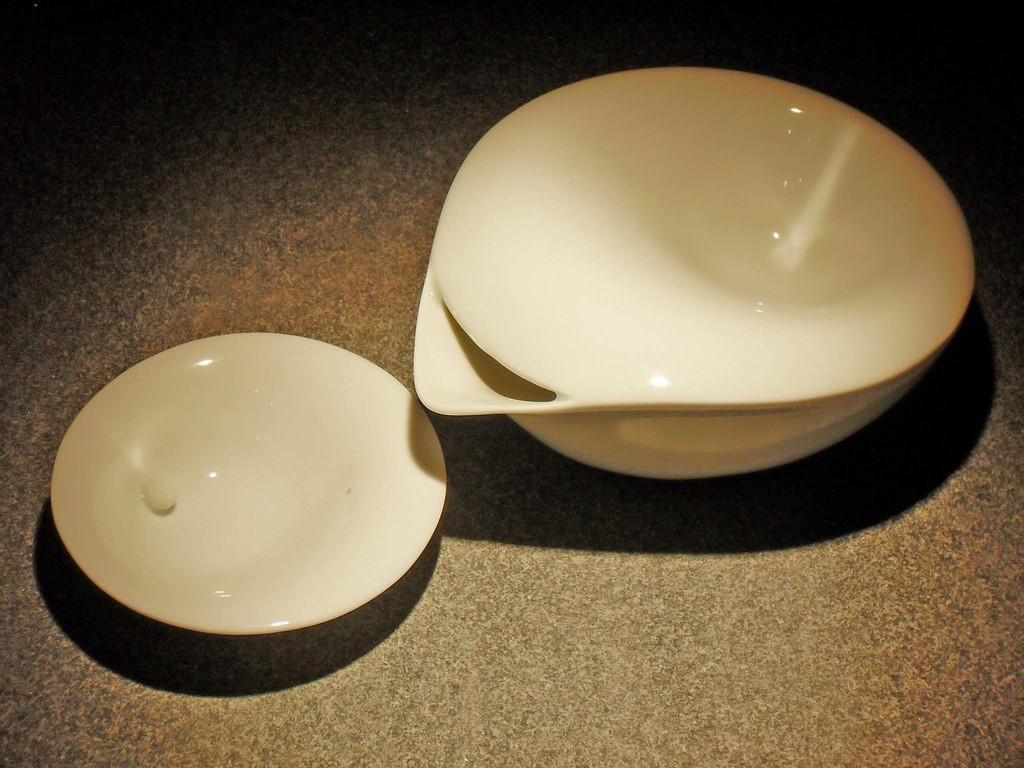Please provide a concise description of this image. In this picture we can see a bowl and a plate on the platform. 